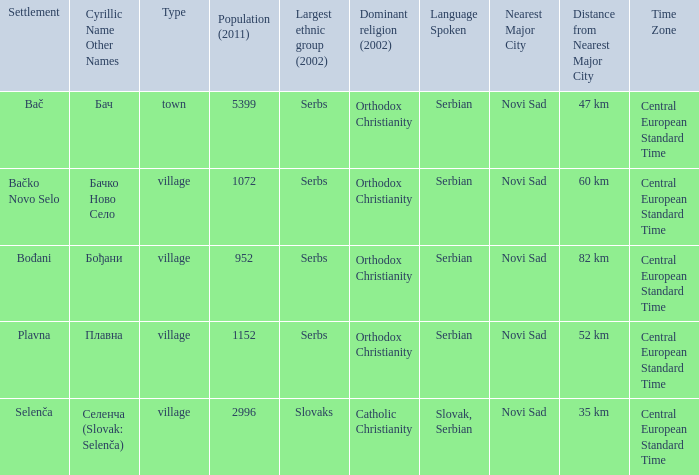How to you write  плавна with the latin alphabet? Plavna. 